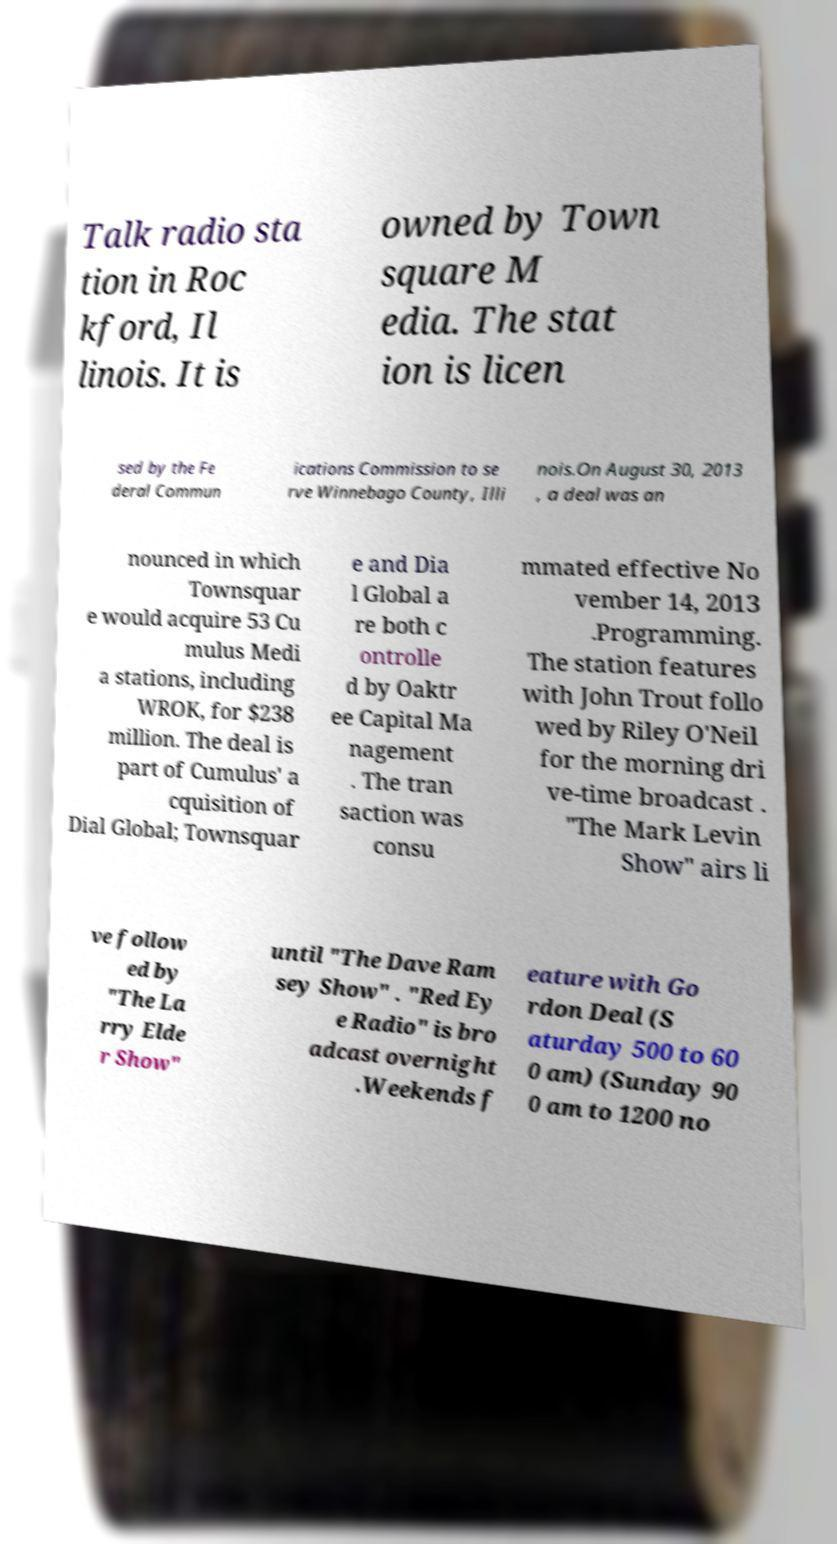Please read and relay the text visible in this image. What does it say? Talk radio sta tion in Roc kford, Il linois. It is owned by Town square M edia. The stat ion is licen sed by the Fe deral Commun ications Commission to se rve Winnebago County, Illi nois.On August 30, 2013 , a deal was an nounced in which Townsquar e would acquire 53 Cu mulus Medi a stations, including WROK, for $238 million. The deal is part of Cumulus' a cquisition of Dial Global; Townsquar e and Dia l Global a re both c ontrolle d by Oaktr ee Capital Ma nagement . The tran saction was consu mmated effective No vember 14, 2013 .Programming. The station features with John Trout follo wed by Riley O'Neil for the morning dri ve-time broadcast . "The Mark Levin Show" airs li ve follow ed by "The La rry Elde r Show" until "The Dave Ram sey Show" . "Red Ey e Radio" is bro adcast overnight .Weekends f eature with Go rdon Deal (S aturday 500 to 60 0 am) (Sunday 90 0 am to 1200 no 